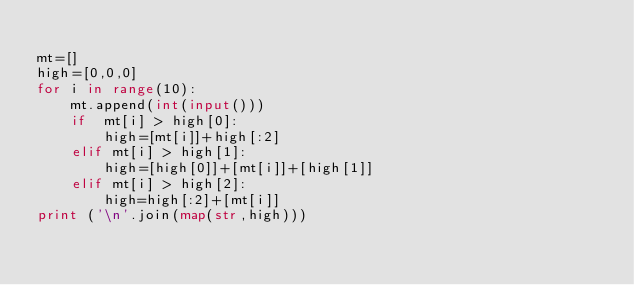<code> <loc_0><loc_0><loc_500><loc_500><_Python_>
mt=[]
high=[0,0,0]
for i in range(10):
    mt.append(int(input()))
    if  mt[i] > high[0]:
        high=[mt[i]]+high[:2]
    elif mt[i] > high[1]:
        high=[high[0]]+[mt[i]]+[high[1]]
    elif mt[i] > high[2]:
        high=high[:2]+[mt[i]]
print ('\n'.join(map(str,high)))</code> 